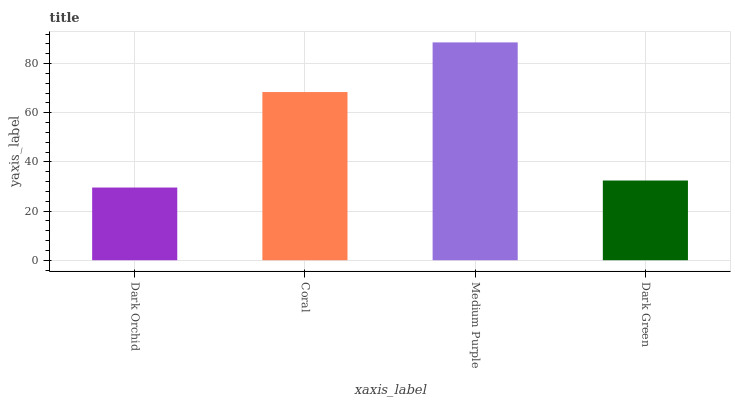Is Coral the minimum?
Answer yes or no. No. Is Coral the maximum?
Answer yes or no. No. Is Coral greater than Dark Orchid?
Answer yes or no. Yes. Is Dark Orchid less than Coral?
Answer yes or no. Yes. Is Dark Orchid greater than Coral?
Answer yes or no. No. Is Coral less than Dark Orchid?
Answer yes or no. No. Is Coral the high median?
Answer yes or no. Yes. Is Dark Green the low median?
Answer yes or no. Yes. Is Dark Orchid the high median?
Answer yes or no. No. Is Dark Orchid the low median?
Answer yes or no. No. 